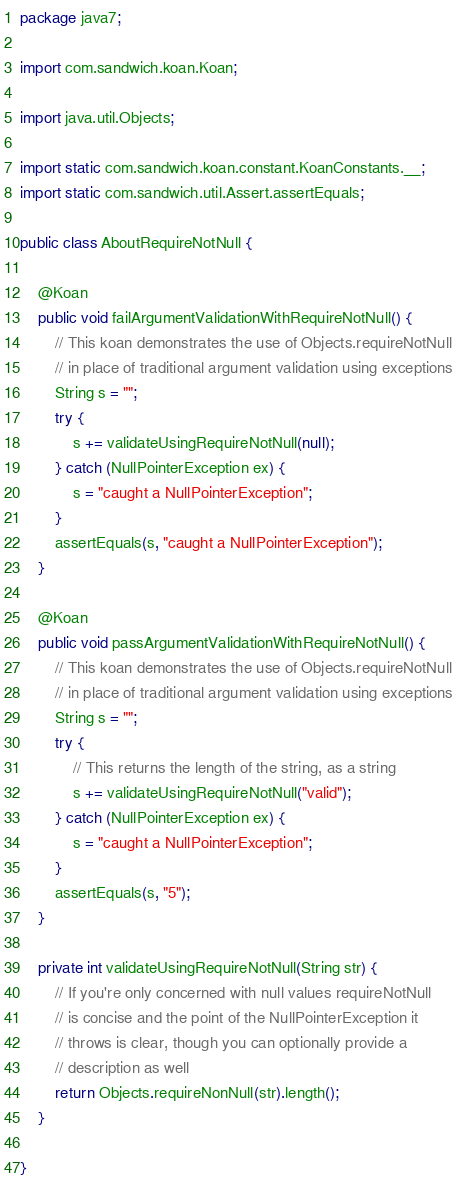<code> <loc_0><loc_0><loc_500><loc_500><_Java_>package java7;

import com.sandwich.koan.Koan;

import java.util.Objects;

import static com.sandwich.koan.constant.KoanConstants.__;
import static com.sandwich.util.Assert.assertEquals;

public class AboutRequireNotNull {

    @Koan
    public void failArgumentValidationWithRequireNotNull() {
        // This koan demonstrates the use of Objects.requireNotNull
        // in place of traditional argument validation using exceptions
        String s = "";
        try {
            s += validateUsingRequireNotNull(null);
        } catch (NullPointerException ex) {
            s = "caught a NullPointerException";
        }
        assertEquals(s, "caught a NullPointerException");
    }

    @Koan
    public void passArgumentValidationWithRequireNotNull() {
        // This koan demonstrates the use of Objects.requireNotNull
        // in place of traditional argument validation using exceptions
        String s = "";
        try {
            // This returns the length of the string, as a string
            s += validateUsingRequireNotNull("valid");
        } catch (NullPointerException ex) {
            s = "caught a NullPointerException";
        }
        assertEquals(s, "5");
    }

    private int validateUsingRequireNotNull(String str) {
        // If you're only concerned with null values requireNotNull
        // is concise and the point of the NullPointerException it
        // throws is clear, though you can optionally provide a
        // description as well
        return Objects.requireNonNull(str).length();
    }

}
</code> 